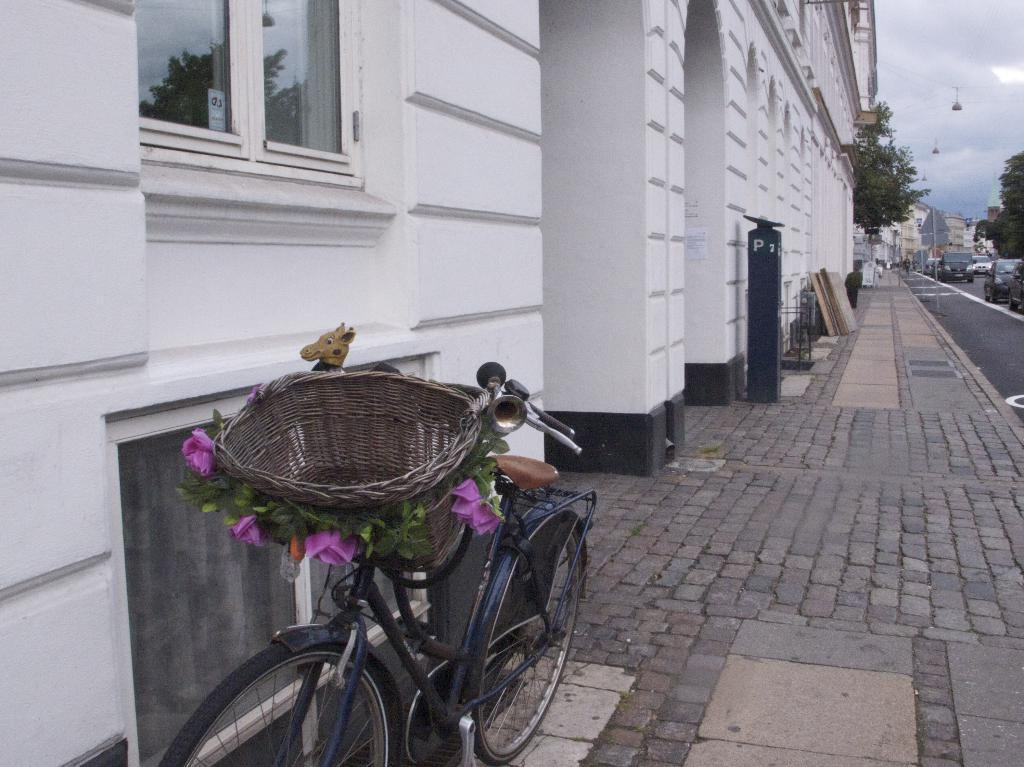What type of structures can be seen in the image? There are buildings in the image. What mode of transportation can be seen in the image? There are bicycles and motor vehicles on the road in the image. What type of signage is present in the image? There are sign boards in the image. What type of transportation is not present on the ground but in the air? There is a rope way in the image. What type of natural elements can be seen in the image? There are trees in the image. What part of the natural environment is visible in the image? The sky is visible in the image, and clouds are present in the sky. Where is the pot with brass decorations located in the image? There is no pot with brass decorations present in the image. What type of bird's nest can be seen in the trees in the image? There are no bird's nests visible in the trees in the image. 